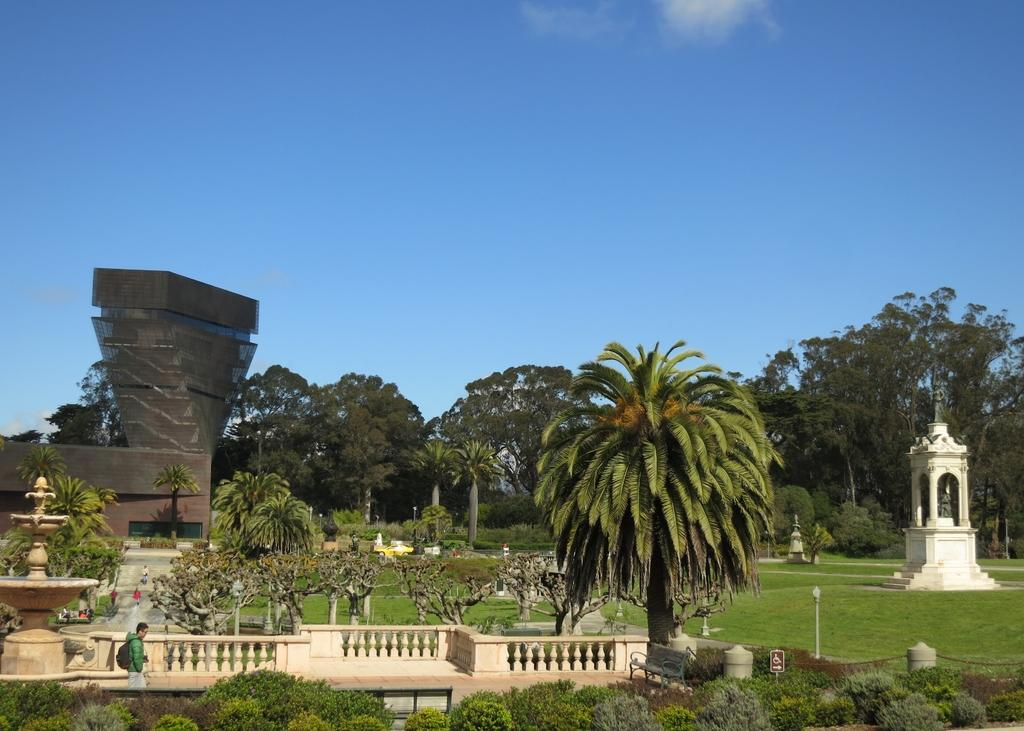What type of location is depicted in the image? The image appears to depict a park. What type of vegetation can be seen in the image? There are trees in the image. What type of structures are present in the image? There are monuments in the image. What is the man on the left side of the image doing? The man is walking on the left side of the image. What is visible at the top of the image? The sky is visible at the top of the image. What type of eggnog is being served at the park in the image? There is no eggnog present in the image, and therefore no such activity can be observed. Can you tell me which actor is performing at the park in the image? There is no actor performing at the park in the image. 